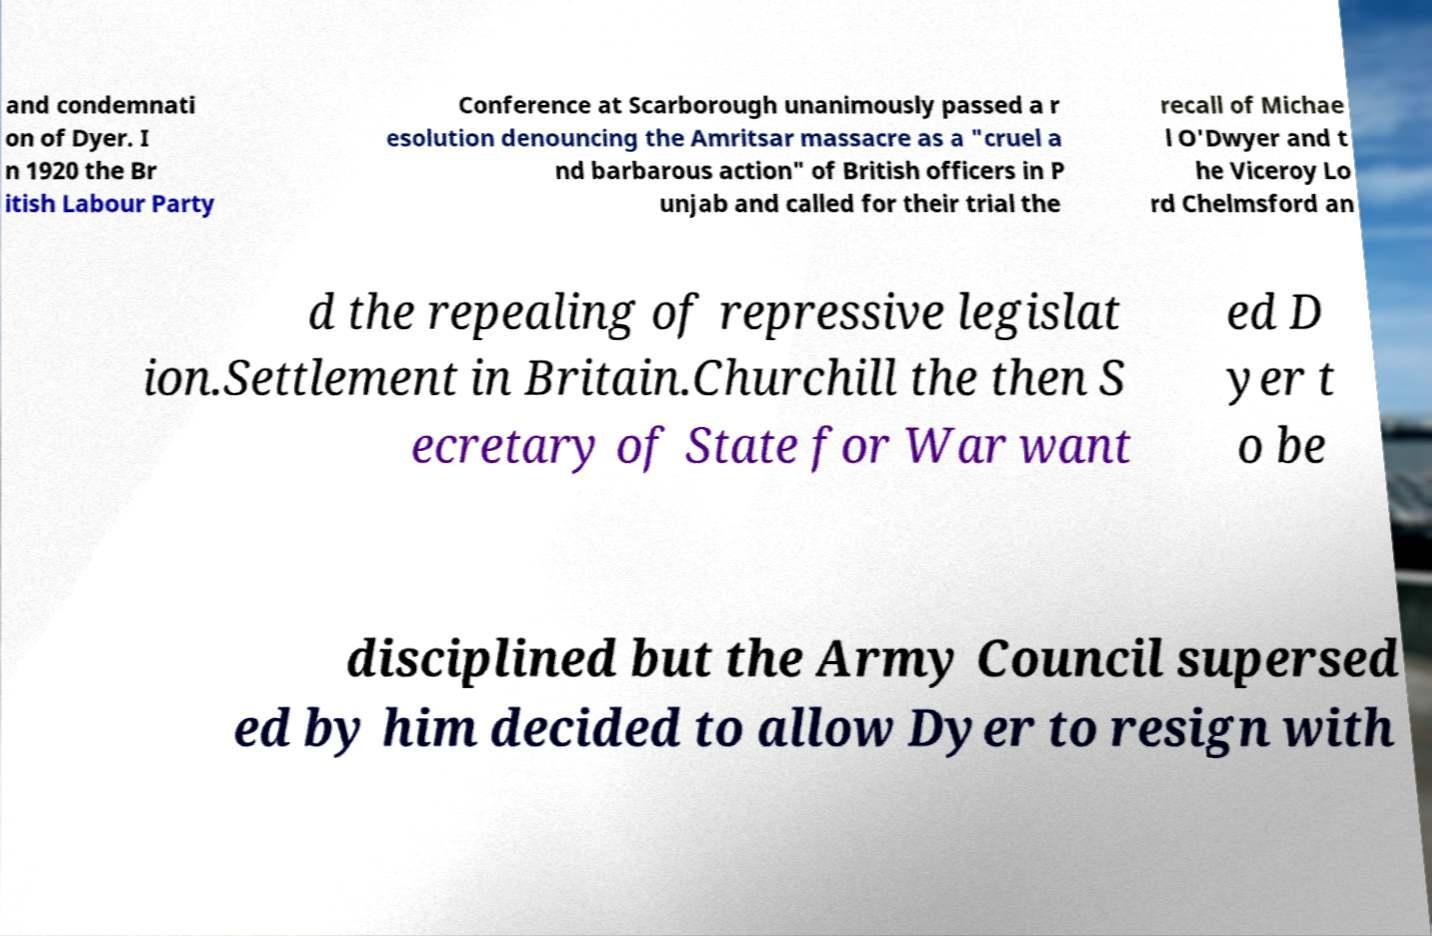I need the written content from this picture converted into text. Can you do that? and condemnati on of Dyer. I n 1920 the Br itish Labour Party Conference at Scarborough unanimously passed a r esolution denouncing the Amritsar massacre as a "cruel a nd barbarous action" of British officers in P unjab and called for their trial the recall of Michae l O'Dwyer and t he Viceroy Lo rd Chelmsford an d the repealing of repressive legislat ion.Settlement in Britain.Churchill the then S ecretary of State for War want ed D yer t o be disciplined but the Army Council supersed ed by him decided to allow Dyer to resign with 